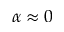<formula> <loc_0><loc_0><loc_500><loc_500>\alpha \approx 0</formula> 